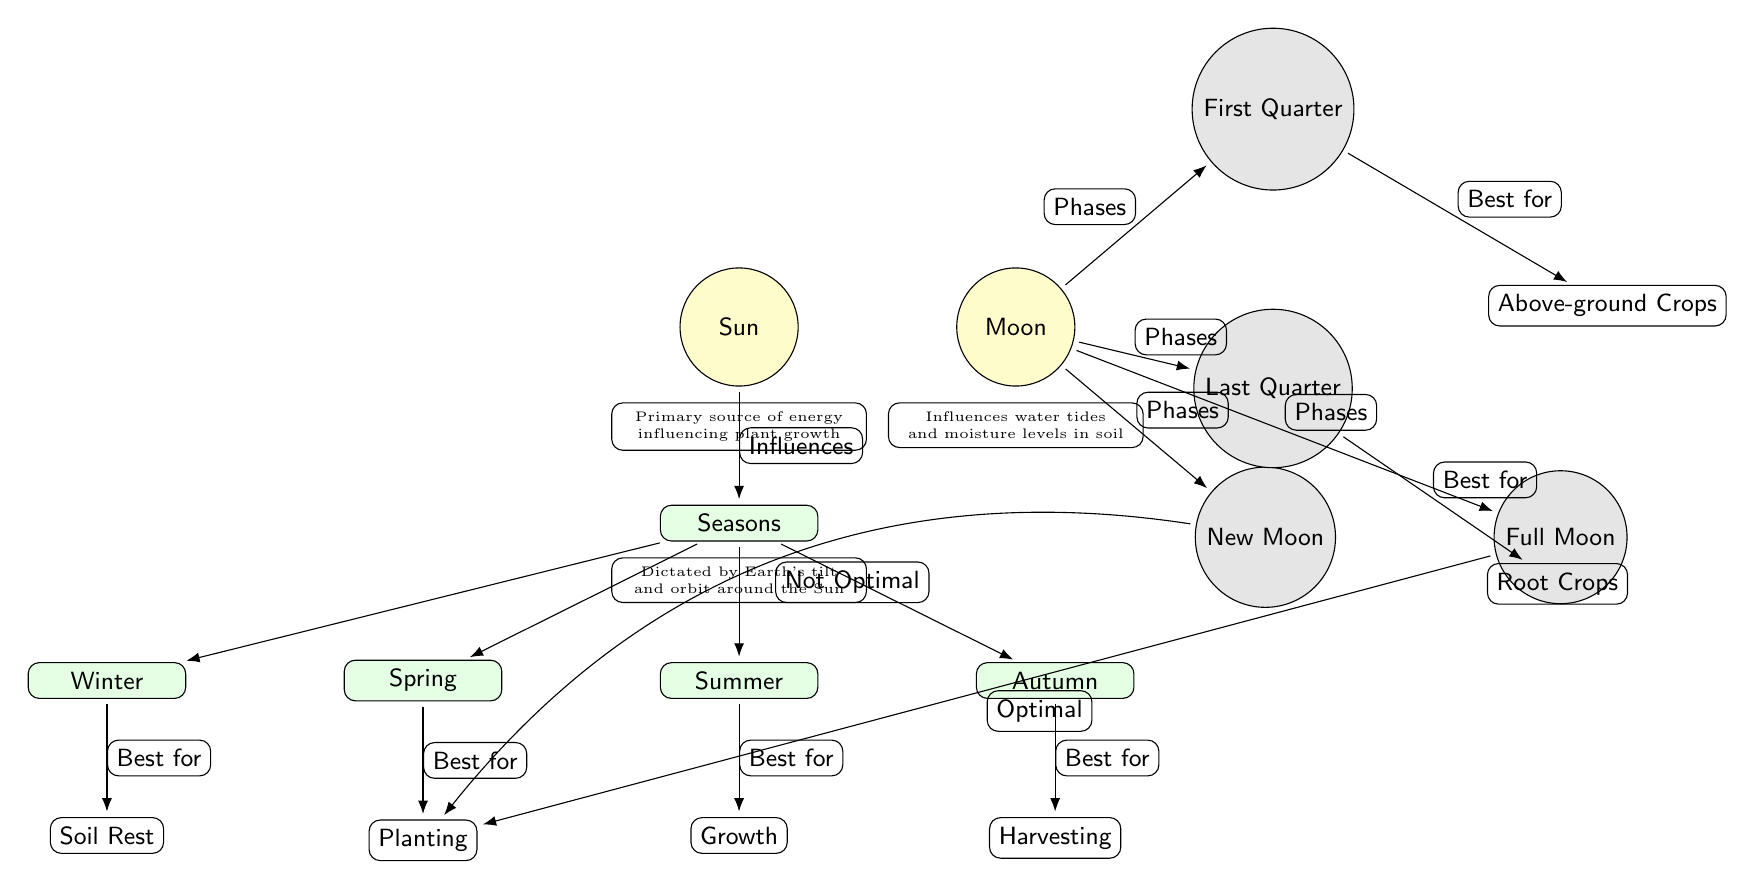What are the four seasons depicted in the diagram? The diagram clearly lists the four seasons directly below the season node: Winter, Spring, Summer, and Autumn.
Answer: Winter, Spring, Summer, Autumn What phase of the moon is best for planting? Looking at the diagram, the edge from "Full Moon" to "Planting" indicates that it is considered "Optimal" for planting.
Answer: Full Moon Which season is indicated as best for soil rest? The diagram specifies that "Soil Rest" is directly connected to "Winter," indicating that winter is the season designated for this activity.
Answer: Winter What agricultural activity is linked to summer? The diagram indicates that "Growth" is connected to "Summer" as the best agricultural activity during that season.
Answer: Growth How many moon phases are represented in the diagram? The diagram shows four distinct moon phases—the New Moon, Full Moon, First Quarter, and Last Quarter, totaling four phases.
Answer: Four What crops are best planted during the first quarter's phase of the moon? According to the connections in the diagram, the "First Quarter" phase is best for planting "Above-ground Crops."
Answer: Above-ground Crops Which season is linked to harvesting? The diagram shows that "Harvesting" is connected to "Autumn," specifying that this is the season for harvesting crops.
Answer: Autumn What activity is associated with the new moon phase? The diagram indicates that "New Moon" is connected to "Planting" but labeled as "Not Optimal," suggesting that while it's linked to planting, it's not the best time.
Answer: Not Optimal Explain the relationship between solar influence and agricultural activities in spring. The "Sun" influences "Seasons," and "Spring" is connected to "Planting," which implies that the Sun's influence on seasons leads to planting during spring.
Answer: Planting 